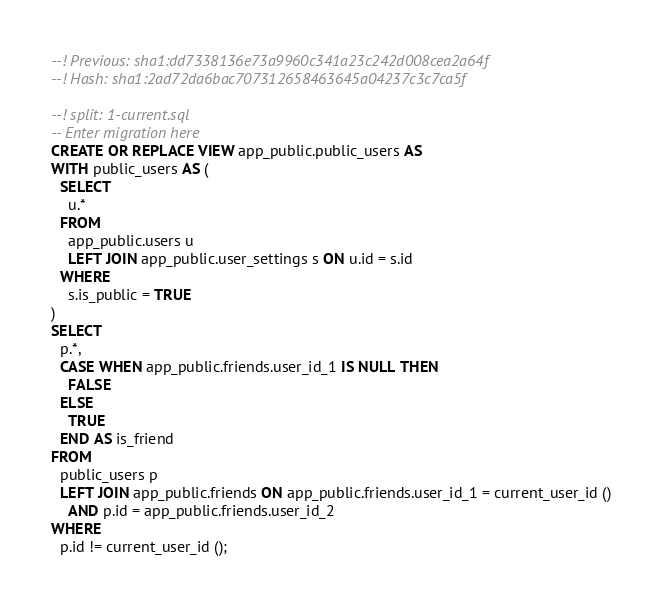Convert code to text. <code><loc_0><loc_0><loc_500><loc_500><_SQL_>--! Previous: sha1:dd7338136e73a9960c341a23c242d008cea2a64f
--! Hash: sha1:2ad72da6bac707312658463645a04237c3c7ca5f

--! split: 1-current.sql
-- Enter migration here
CREATE OR REPLACE VIEW app_public.public_users AS
WITH public_users AS (
  SELECT
    u.*
  FROM
    app_public.users u
    LEFT JOIN app_public.user_settings s ON u.id = s.id
  WHERE
    s.is_public = TRUE
)
SELECT
  p.*,
  CASE WHEN app_public.friends.user_id_1 IS NULL THEN
    FALSE
  ELSE
    TRUE
  END AS is_friend
FROM
  public_users p
  LEFT JOIN app_public.friends ON app_public.friends.user_id_1 = current_user_id ()
    AND p.id = app_public.friends.user_id_2
WHERE
  p.id != current_user_id ();
</code> 